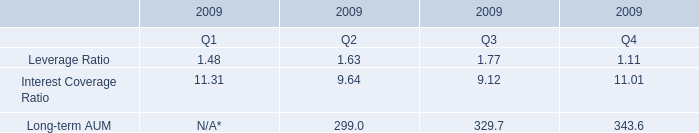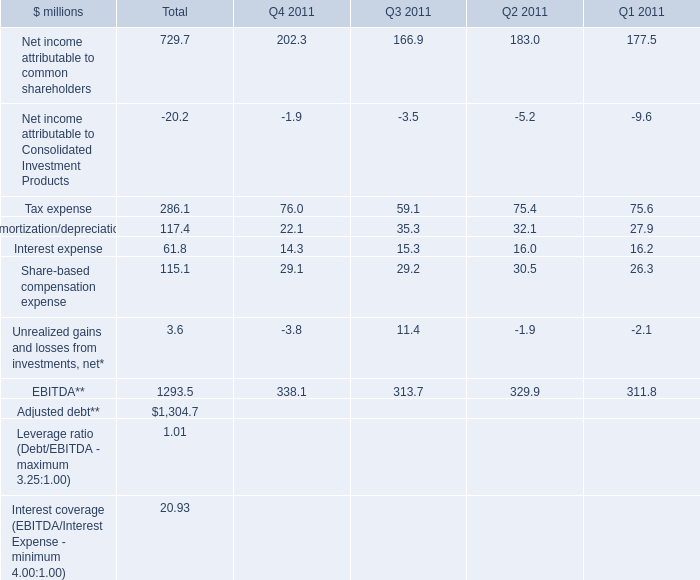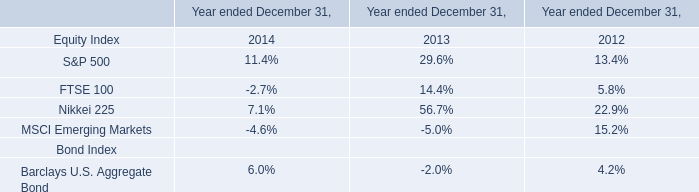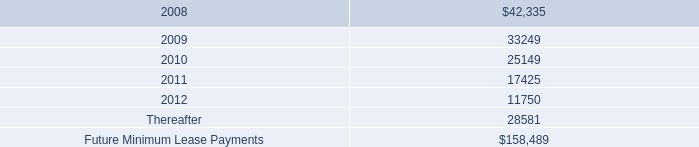what was the average rental expense from 2005 to 2007 in millions 
Computations: ((((27.4 + 18.6) + 12.2) + 3) / 2)
Answer: 30.6. 